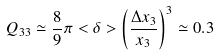<formula> <loc_0><loc_0><loc_500><loc_500>Q _ { 3 3 } \simeq \frac { 8 } { 9 } \pi < \delta > \left ( \frac { \Delta x _ { 3 } } { x _ { 3 } } \right ) ^ { 3 } \simeq 0 . 3</formula> 